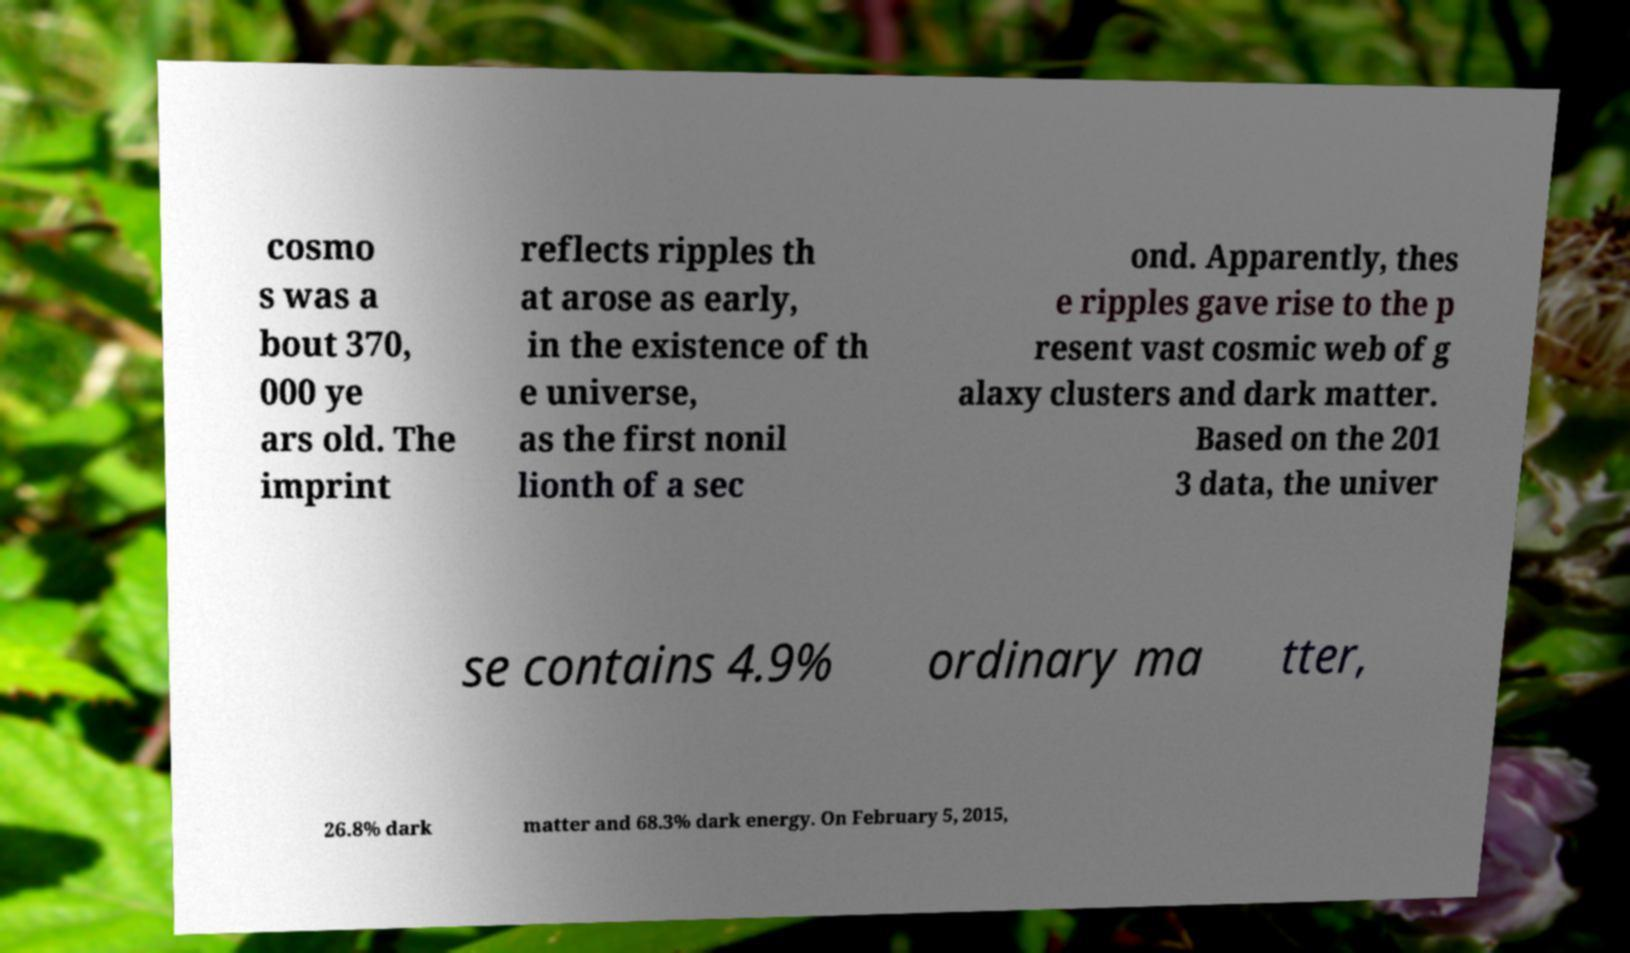Can you accurately transcribe the text from the provided image for me? cosmo s was a bout 370, 000 ye ars old. The imprint reflects ripples th at arose as early, in the existence of th e universe, as the first nonil lionth of a sec ond. Apparently, thes e ripples gave rise to the p resent vast cosmic web of g alaxy clusters and dark matter. Based on the 201 3 data, the univer se contains 4.9% ordinary ma tter, 26.8% dark matter and 68.3% dark energy. On February 5, 2015, 